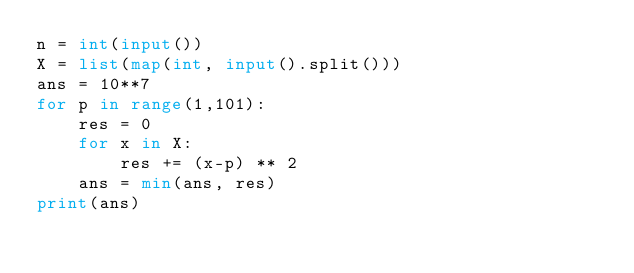Convert code to text. <code><loc_0><loc_0><loc_500><loc_500><_Python_>n = int(input())
X = list(map(int, input().split()))
ans = 10**7
for p in range(1,101):
    res = 0
    for x in X:
        res += (x-p) ** 2
    ans = min(ans, res)
print(ans)</code> 